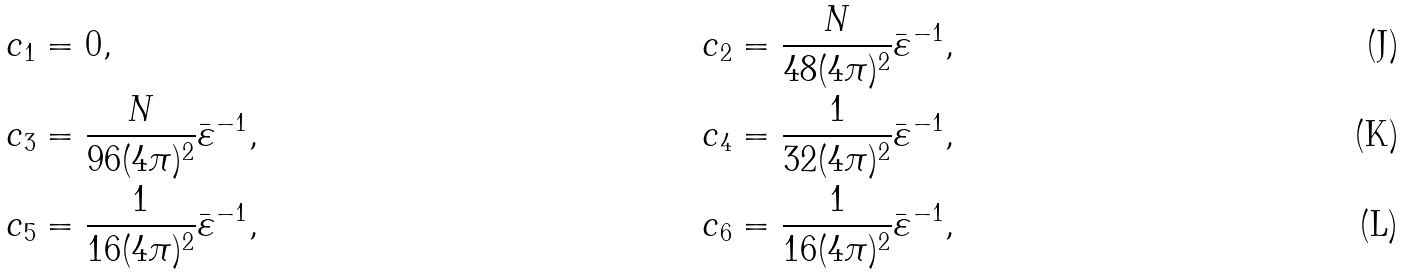Convert formula to latex. <formula><loc_0><loc_0><loc_500><loc_500>& c _ { 1 } = 0 , & c _ { 2 } & = \frac { N } { 4 8 ( 4 \pi ) ^ { 2 } } \bar { \varepsilon } ^ { - 1 } , \\ & c _ { 3 } = \frac { N } { 9 6 ( 4 \pi ) ^ { 2 } } \bar { \varepsilon } ^ { - 1 } , & c _ { 4 } & = \frac { 1 } { 3 2 ( 4 \pi ) ^ { 2 } } \bar { \varepsilon } ^ { - 1 } , \\ & c _ { 5 } = \frac { 1 } { 1 6 ( 4 \pi ) ^ { 2 } } \bar { \varepsilon } ^ { - 1 } , & c _ { 6 } & = \frac { 1 } { 1 6 ( 4 \pi ) ^ { 2 } } \bar { \varepsilon } ^ { - 1 } ,</formula> 